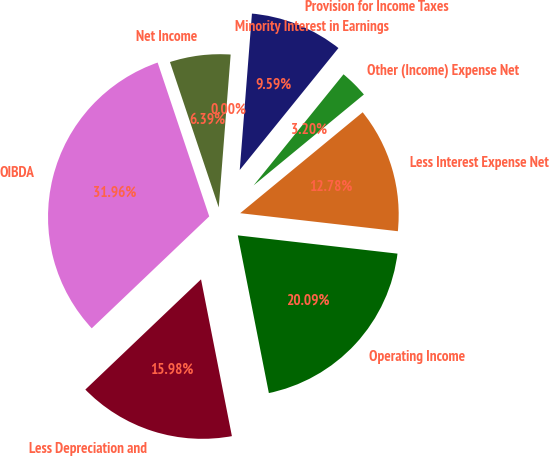Convert chart to OTSL. <chart><loc_0><loc_0><loc_500><loc_500><pie_chart><fcel>OIBDA<fcel>Less Depreciation and<fcel>Operating Income<fcel>Less Interest Expense Net<fcel>Other (Income) Expense Net<fcel>Provision for Income Taxes<fcel>Minority Interest in Earnings<fcel>Net Income<nl><fcel>31.96%<fcel>15.98%<fcel>20.09%<fcel>12.78%<fcel>3.2%<fcel>9.59%<fcel>0.0%<fcel>6.39%<nl></chart> 